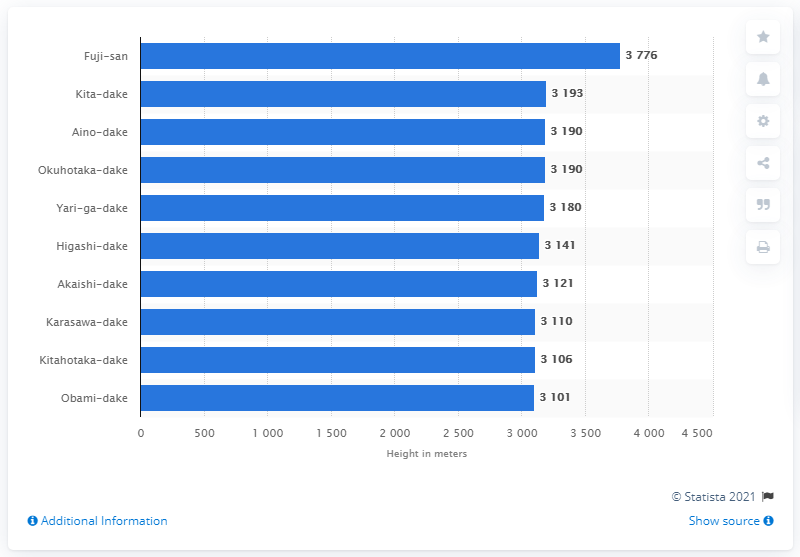Specify some key components in this picture. Kita-dake is the second tallest mountain in Japan. 